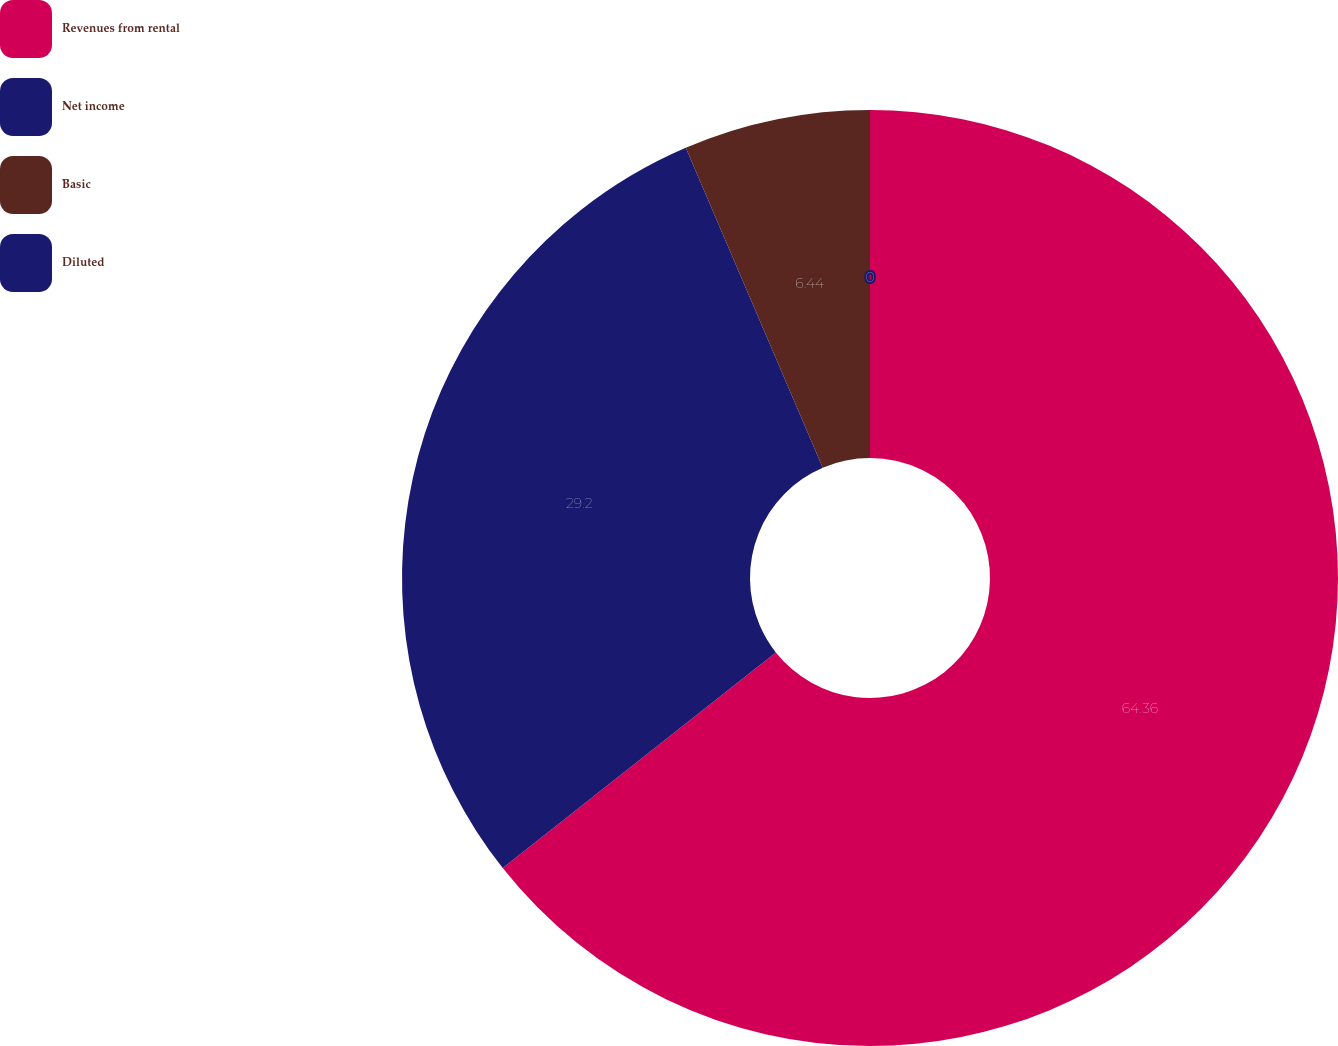Convert chart to OTSL. <chart><loc_0><loc_0><loc_500><loc_500><pie_chart><fcel>Revenues from rental<fcel>Net income<fcel>Basic<fcel>Diluted<nl><fcel>64.36%<fcel>29.2%<fcel>6.44%<fcel>0.0%<nl></chart> 